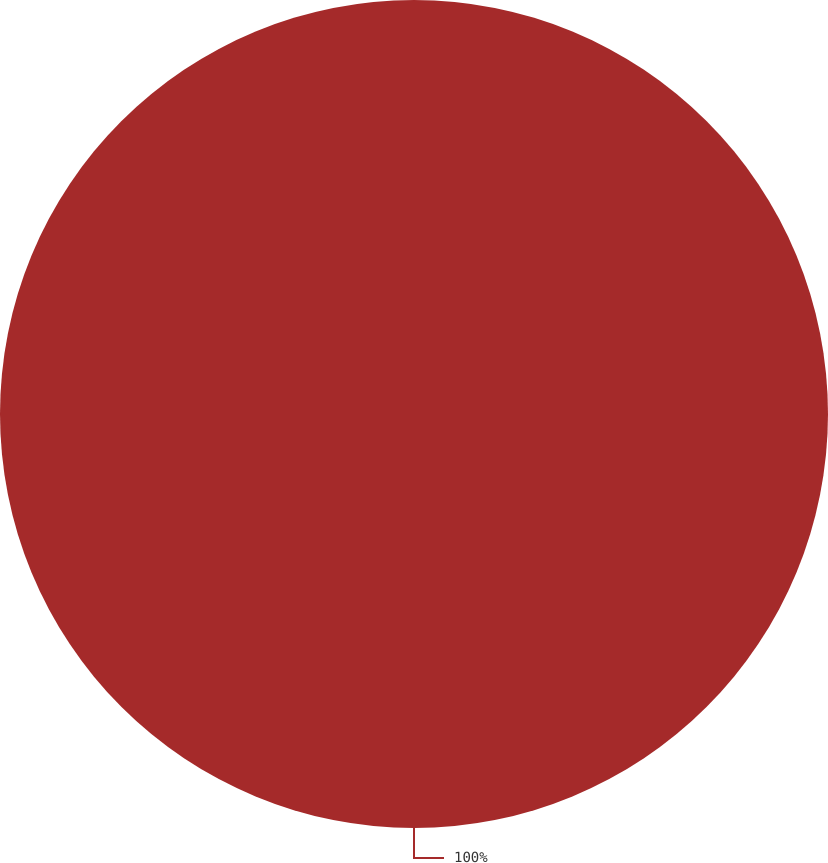<chart> <loc_0><loc_0><loc_500><loc_500><pie_chart><ecel><nl><fcel>100.0%<nl></chart> 